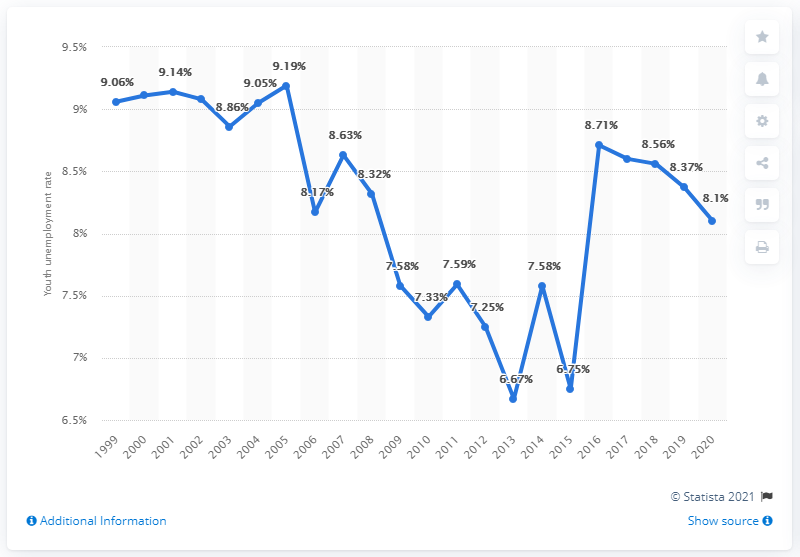Indicate a few pertinent items in this graphic. In 2020, the youth unemployment rate in Peru was 8.1%. 